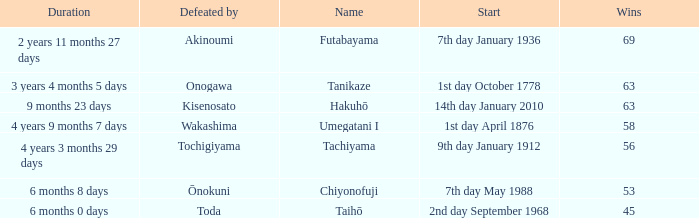How many wins were held before being defeated by toda? 1.0. 